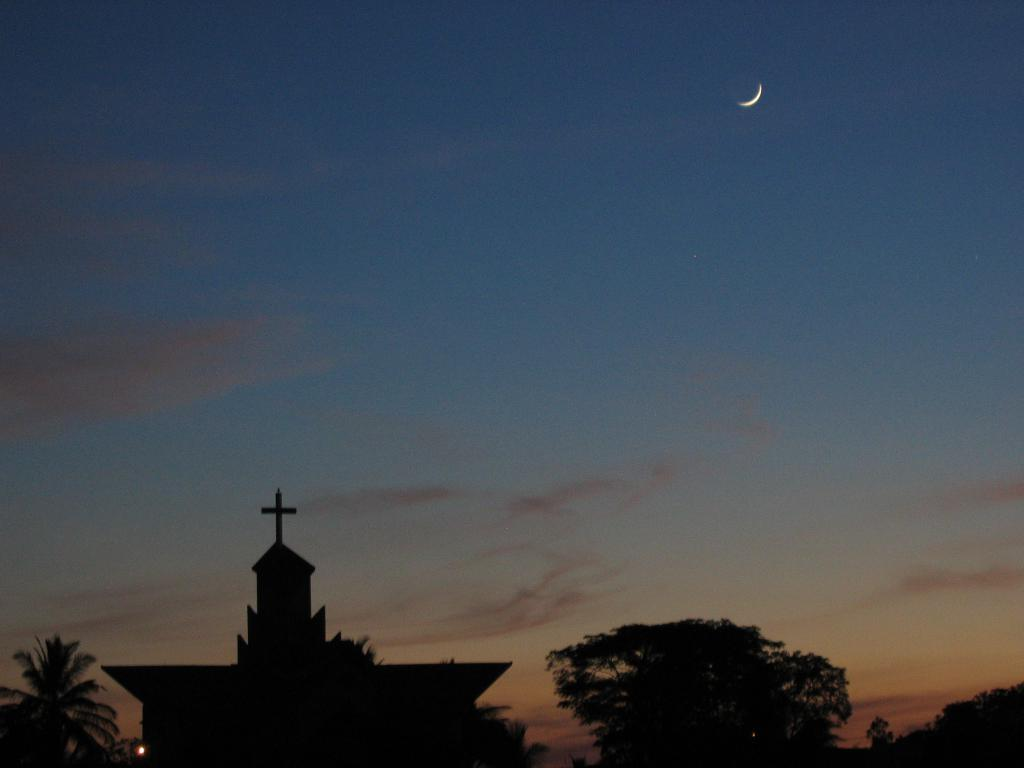What type of structure is present in the picture? There is a house in the picture. What other natural elements can be seen in the picture? There are trees in the picture. What celestial body is visible in the sky in the background of the picture? The moon is visible in the sky in the background of the picture. What type of lipstick is the house wearing in the picture? There is no lipstick or any indication of a mouth in the picture; it is a house with trees and the moon visible in the sky. 